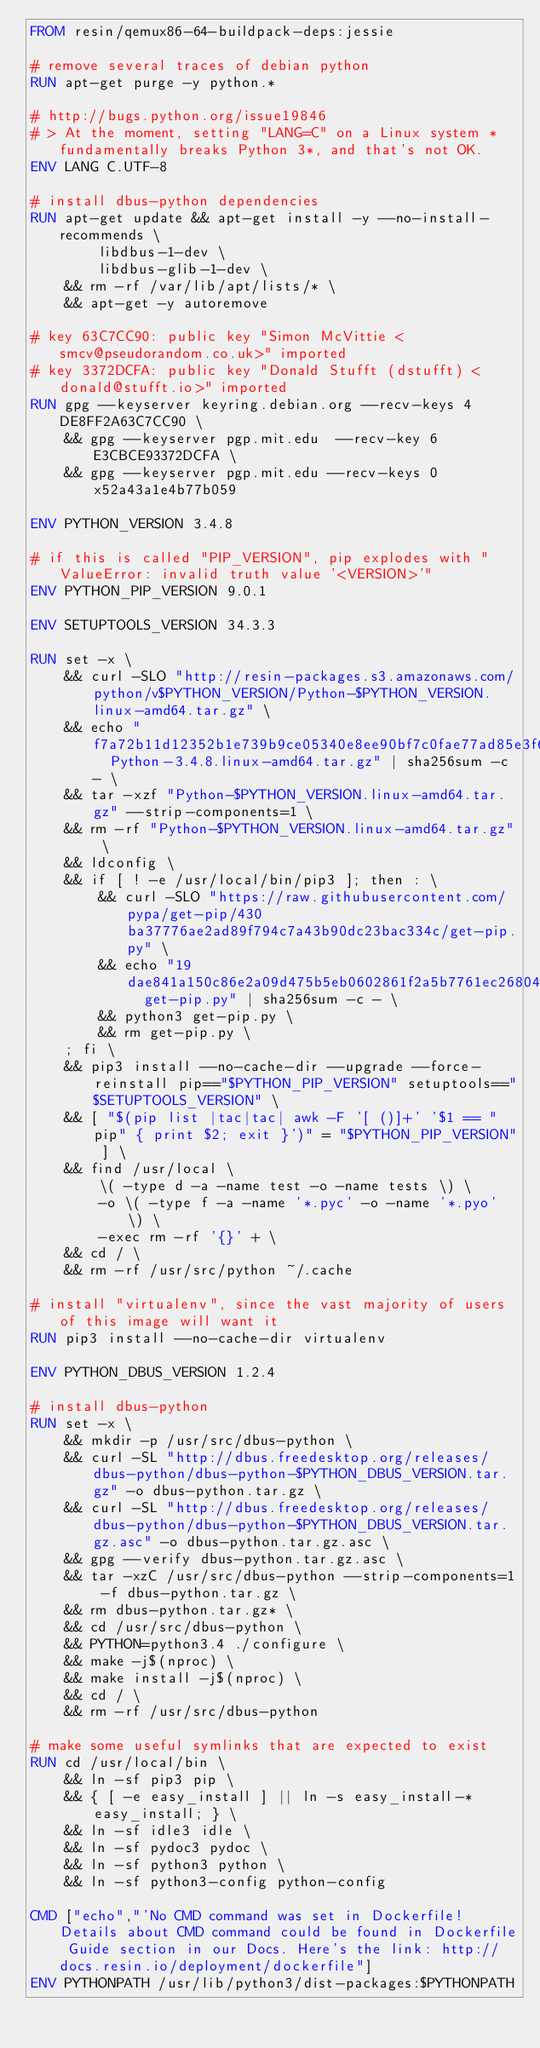Convert code to text. <code><loc_0><loc_0><loc_500><loc_500><_Dockerfile_>FROM resin/qemux86-64-buildpack-deps:jessie

# remove several traces of debian python
RUN apt-get purge -y python.*

# http://bugs.python.org/issue19846
# > At the moment, setting "LANG=C" on a Linux system *fundamentally breaks Python 3*, and that's not OK.
ENV LANG C.UTF-8

# install dbus-python dependencies 
RUN apt-get update && apt-get install -y --no-install-recommends \
		libdbus-1-dev \
		libdbus-glib-1-dev \
	&& rm -rf /var/lib/apt/lists/* \
	&& apt-get -y autoremove

# key 63C7CC90: public key "Simon McVittie <smcv@pseudorandom.co.uk>" imported
# key 3372DCFA: public key "Donald Stufft (dstufft) <donald@stufft.io>" imported
RUN gpg --keyserver keyring.debian.org --recv-keys 4DE8FF2A63C7CC90 \
	&& gpg --keyserver pgp.mit.edu  --recv-key 6E3CBCE93372DCFA \
	&& gpg --keyserver pgp.mit.edu --recv-keys 0x52a43a1e4b77b059

ENV PYTHON_VERSION 3.4.8

# if this is called "PIP_VERSION", pip explodes with "ValueError: invalid truth value '<VERSION>'"
ENV PYTHON_PIP_VERSION 9.0.1

ENV SETUPTOOLS_VERSION 34.3.3

RUN set -x \
	&& curl -SLO "http://resin-packages.s3.amazonaws.com/python/v$PYTHON_VERSION/Python-$PYTHON_VERSION.linux-amd64.tar.gz" \
	&& echo "f7a72b11d12352b1e739b9ce05340e8ee90bf7c0fae77ad85e3f6a04ce35f5fc  Python-3.4.8.linux-amd64.tar.gz" | sha256sum -c - \
	&& tar -xzf "Python-$PYTHON_VERSION.linux-amd64.tar.gz" --strip-components=1 \
	&& rm -rf "Python-$PYTHON_VERSION.linux-amd64.tar.gz" \
	&& ldconfig \
	&& if [ ! -e /usr/local/bin/pip3 ]; then : \
		&& curl -SLO "https://raw.githubusercontent.com/pypa/get-pip/430ba37776ae2ad89f794c7a43b90dc23bac334c/get-pip.py" \
		&& echo "19dae841a150c86e2a09d475b5eb0602861f2a5b7761ec268049a662dbd2bd0c  get-pip.py" | sha256sum -c - \
		&& python3 get-pip.py \
		&& rm get-pip.py \
	; fi \
	&& pip3 install --no-cache-dir --upgrade --force-reinstall pip=="$PYTHON_PIP_VERSION" setuptools=="$SETUPTOOLS_VERSION" \
	&& [ "$(pip list |tac|tac| awk -F '[ ()]+' '$1 == "pip" { print $2; exit }')" = "$PYTHON_PIP_VERSION" ] \
	&& find /usr/local \
		\( -type d -a -name test -o -name tests \) \
		-o \( -type f -a -name '*.pyc' -o -name '*.pyo' \) \
		-exec rm -rf '{}' + \
	&& cd / \
	&& rm -rf /usr/src/python ~/.cache

# install "virtualenv", since the vast majority of users of this image will want it
RUN pip3 install --no-cache-dir virtualenv

ENV PYTHON_DBUS_VERSION 1.2.4

# install dbus-python
RUN set -x \
	&& mkdir -p /usr/src/dbus-python \
	&& curl -SL "http://dbus.freedesktop.org/releases/dbus-python/dbus-python-$PYTHON_DBUS_VERSION.tar.gz" -o dbus-python.tar.gz \
	&& curl -SL "http://dbus.freedesktop.org/releases/dbus-python/dbus-python-$PYTHON_DBUS_VERSION.tar.gz.asc" -o dbus-python.tar.gz.asc \
	&& gpg --verify dbus-python.tar.gz.asc \
	&& tar -xzC /usr/src/dbus-python --strip-components=1 -f dbus-python.tar.gz \
	&& rm dbus-python.tar.gz* \
	&& cd /usr/src/dbus-python \
	&& PYTHON=python3.4 ./configure \
	&& make -j$(nproc) \
	&& make install -j$(nproc) \
	&& cd / \
	&& rm -rf /usr/src/dbus-python

# make some useful symlinks that are expected to exist
RUN cd /usr/local/bin \
	&& ln -sf pip3 pip \
	&& { [ -e easy_install ] || ln -s easy_install-* easy_install; } \
	&& ln -sf idle3 idle \
	&& ln -sf pydoc3 pydoc \
	&& ln -sf python3 python \
	&& ln -sf python3-config python-config

CMD ["echo","'No CMD command was set in Dockerfile! Details about CMD command could be found in Dockerfile Guide section in our Docs. Here's the link: http://docs.resin.io/deployment/dockerfile"]
ENV PYTHONPATH /usr/lib/python3/dist-packages:$PYTHONPATH
</code> 